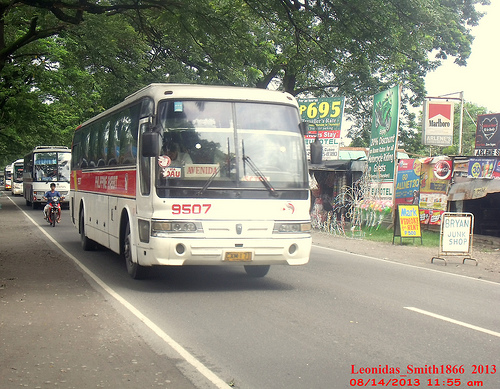Please provide the bounding box coordinate of the region this sentence describes: a rider on a motorcycle. The bounding box coordinate for the rider on a motorcycle is [0.08, 0.47, 0.13, 0.57]. 